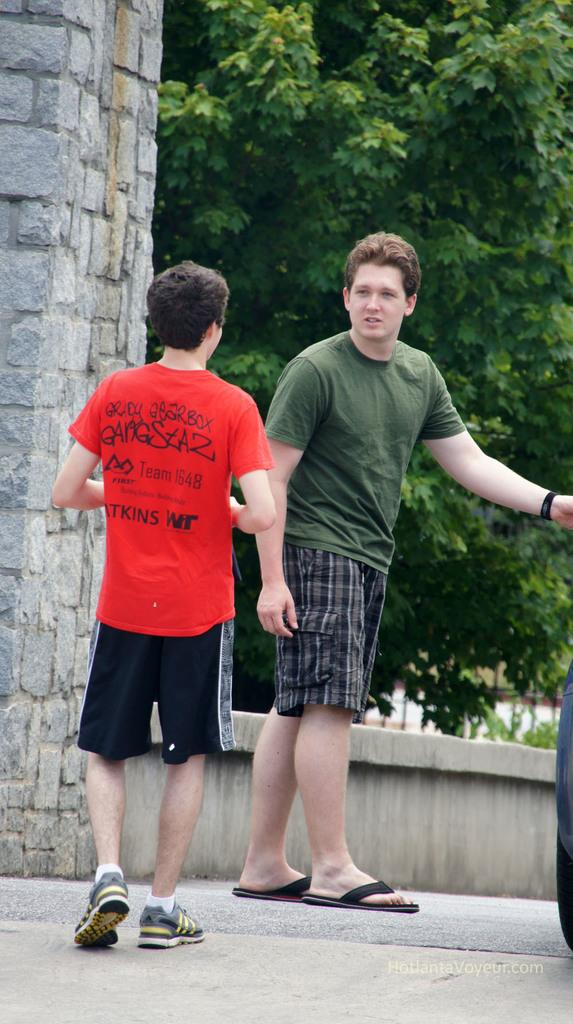How many people are in the image? There are two men in the image. What are the men doing in the image? The men are standing on the road. What can be seen in the background of the image? There are trees in the background of the image. Is there any structure visible in the image? Yes, there is a wall in the image. Can you tell me how many cent coins are on the ground in the image? There are no cent coins visible in the image. Is there a ship in the image? No, there is no ship present in the image. 